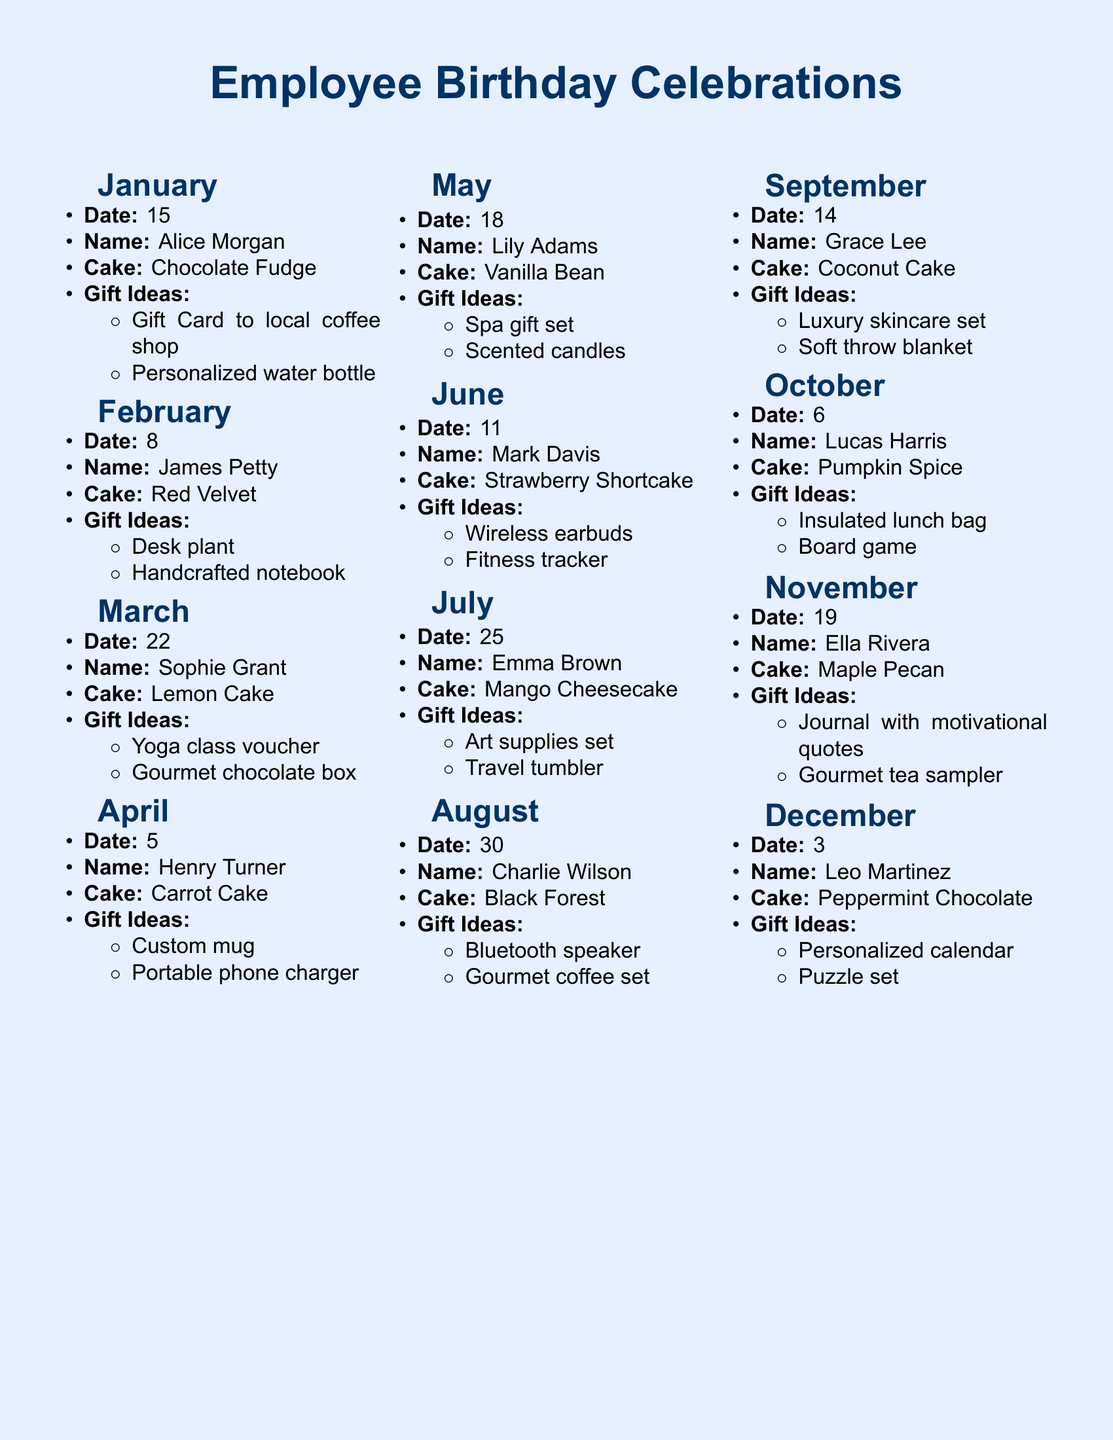What is the birthday month for Emma Brown? Emma Brown's birthday is noted under July in the document.
Answer: July What cake flavor is associated with Henry Turner's birthday? The document lists the cake flavor for Henry Turner as Carrot Cake.
Answer: Carrot Cake Who receives a gift card to a local coffee shop? The document states that Alice Morgan receives this gift on her birthday.
Answer: Alice Morgan Which gift idea is listed for Grace Lee? Grace Lee is suggested to receive a Luxury skincare set as a gift.
Answer: Luxury skincare set When is Lucas Harris's birthday? The date for Lucas Harris's birthday is provided in the document as October 6.
Answer: October 6 What month includes a Strawberry Shortcake celebration? The document indicates that Strawberry Shortcake is celebrated in June.
Answer: June How many employees have birthdays in November? The document lists only one employee, Ella Rivera, with a birthday in November.
Answer: One What is the second gift idea for Lily Adams? The second gift idea for Lily Adams is notated as Scented candles in the document.
Answer: Scented candles What is the flavor of the cake for January's birthday celebration? The document indicates the cake flavor for January is Chocolate Fudge.
Answer: Chocolate Fudge 